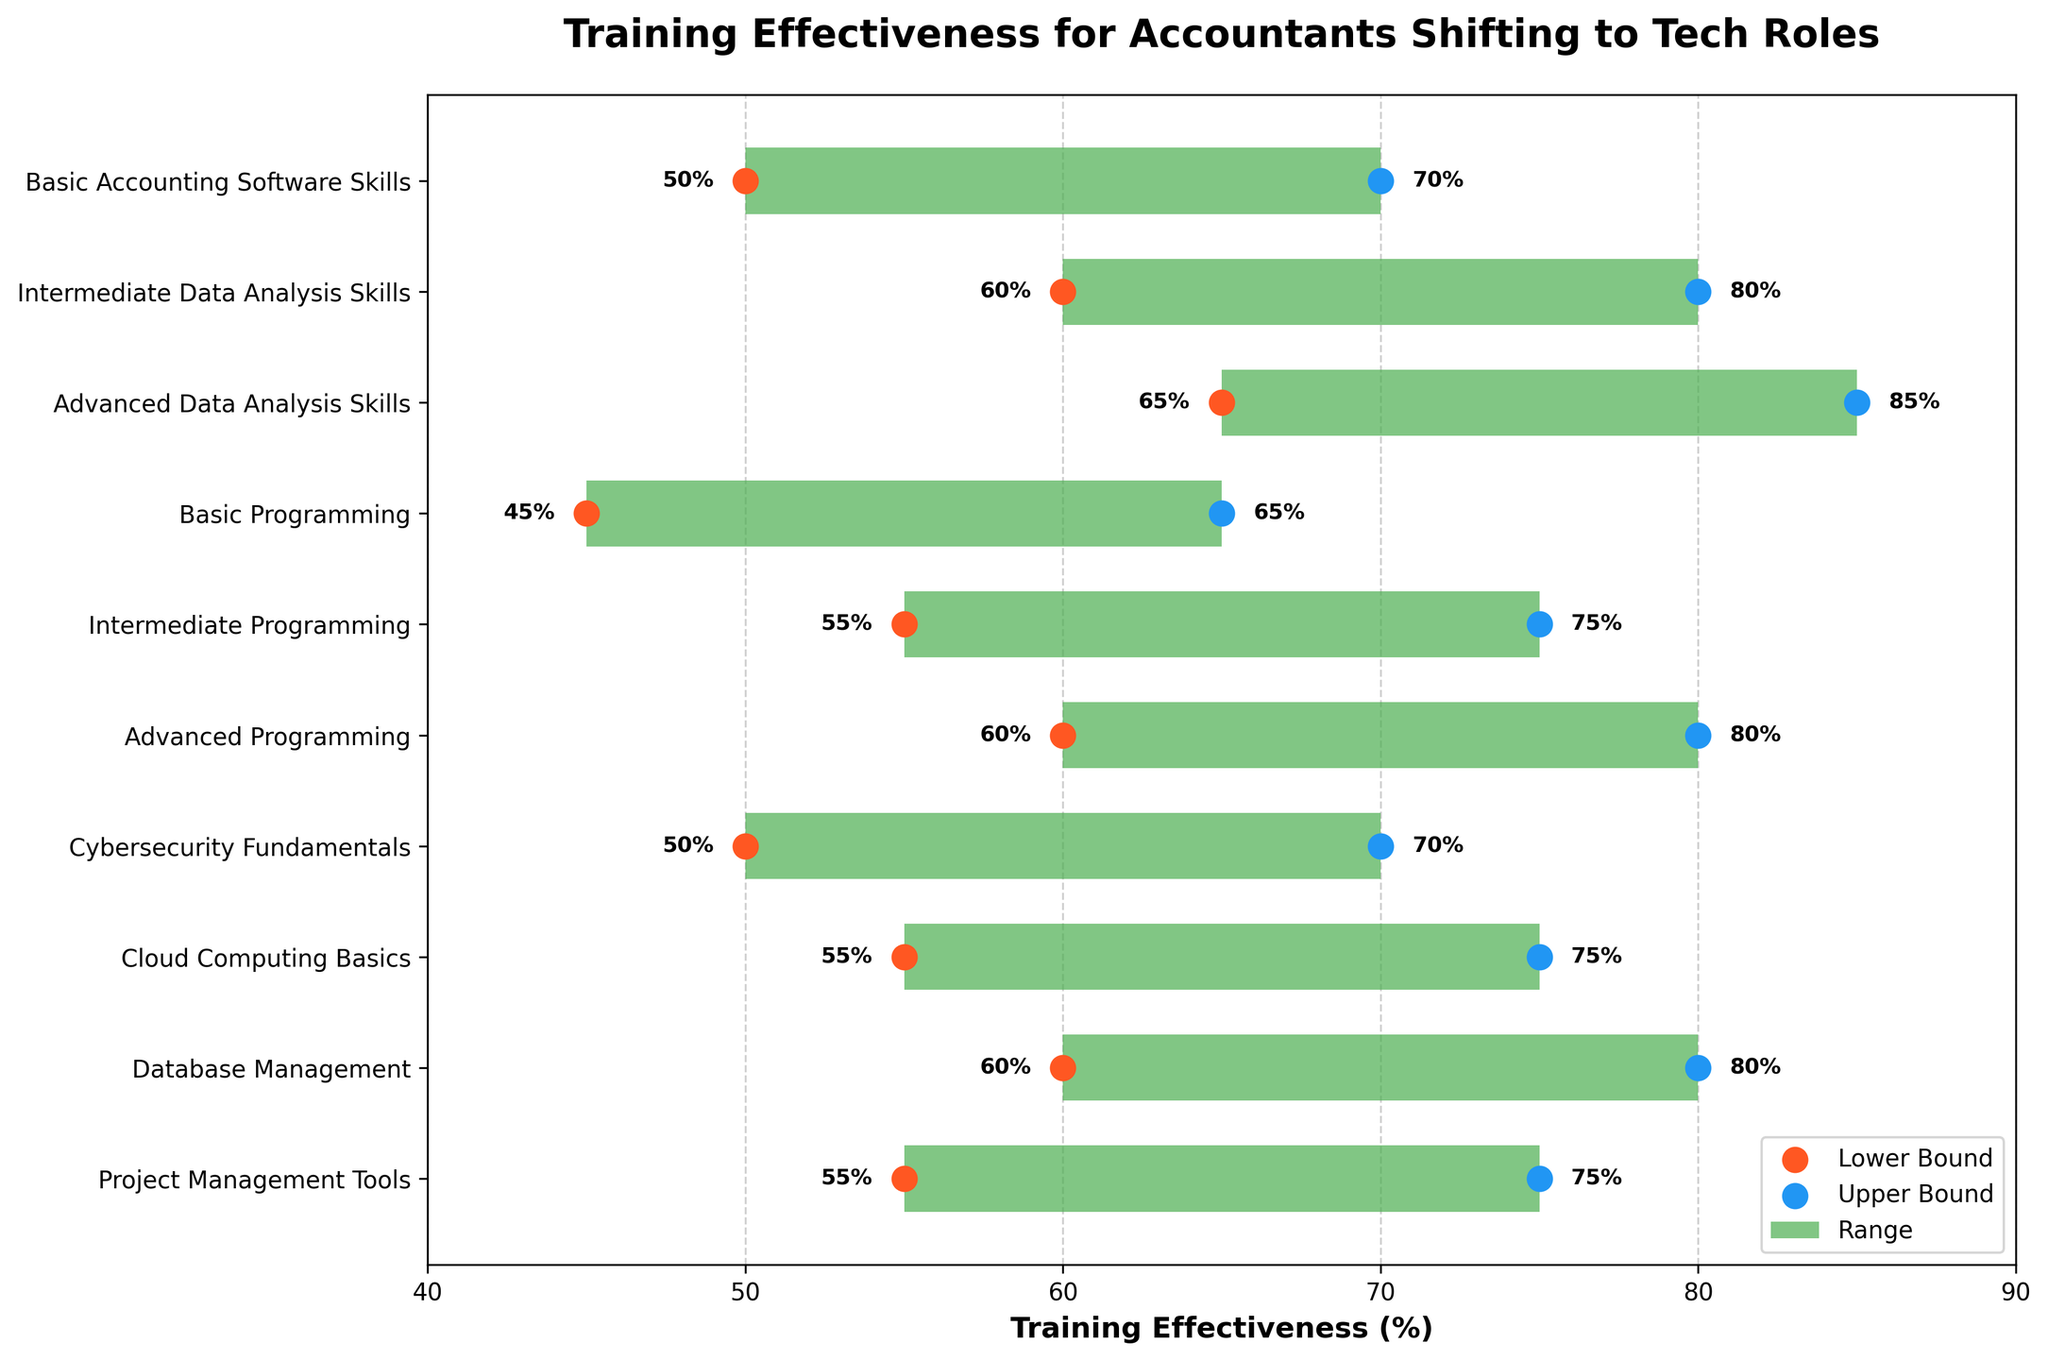What is the title of the chart? The title is located at the top of the chart and can be read directly. It provides an overview of what the chart is about.
Answer: Training Effectiveness for Accountants Shifting to Tech Roles What are the upper bounds of training effectiveness for Intermediate Programming? Locate the "Intermediate Programming" row and check the upper bound percentage to its right.
Answer: 75% Which skills have their lower bounds at 55%? Identify the rows where the lower bound value is 55%.
Answer: Intermediate Programming, Cloud Computing Basics, Project Management Tools What is the range of training effectiveness for Advanced Data Analysis Skills? Calculate the difference between the upper bound and lower bound for "Advanced Data Analysis Skills".
Answer: 20% Which skill shows the highest maximum training effectiveness? Compare the upper bounds of all skills to determine the highest value.
Answer: Advanced Data Analysis Skills (85%) What is the average lower bound of the given skills? Sum all lower bounds and divide by the number of skills.
Answer: (50 + 60 + 65 + 45 + 55 + 60 + 50 + 55 + 60 + 55) / 10 = 55.5% How do Basic Programming and Advanced Programming compare in terms of lower bounds? Compare the lower bound values for Basic Programming (45%) and Advanced Programming (60%).
Answer: Advanced Programming has a higher lower bound What is the difference in the upper bounds between Cybersecurity Fundamentals and Advanced Programming? Subtract the upper bound of Cybersecurity Fundamentals (70%) from that of Advanced Programming (80%).
Answer: 10% Which skill has both its lower and upper bounds closest to each other? Calculate the difference between the upper and lower bounds for each skill and identify the smallest difference.
Answer: Basic Accounting Software Skills (20%) How many skills have an upper bound greater than 75%? Count the number of skills that have their upper bounds greater than 75%.
Answer: Four 